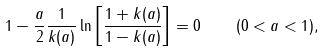<formula> <loc_0><loc_0><loc_500><loc_500>1 - \frac { a } { 2 } \frac { 1 } { k ( a ) } \ln \left [ \frac { 1 + k ( a ) } { 1 - k ( a ) } \right ] = 0 \quad ( 0 < a < 1 ) ,</formula> 